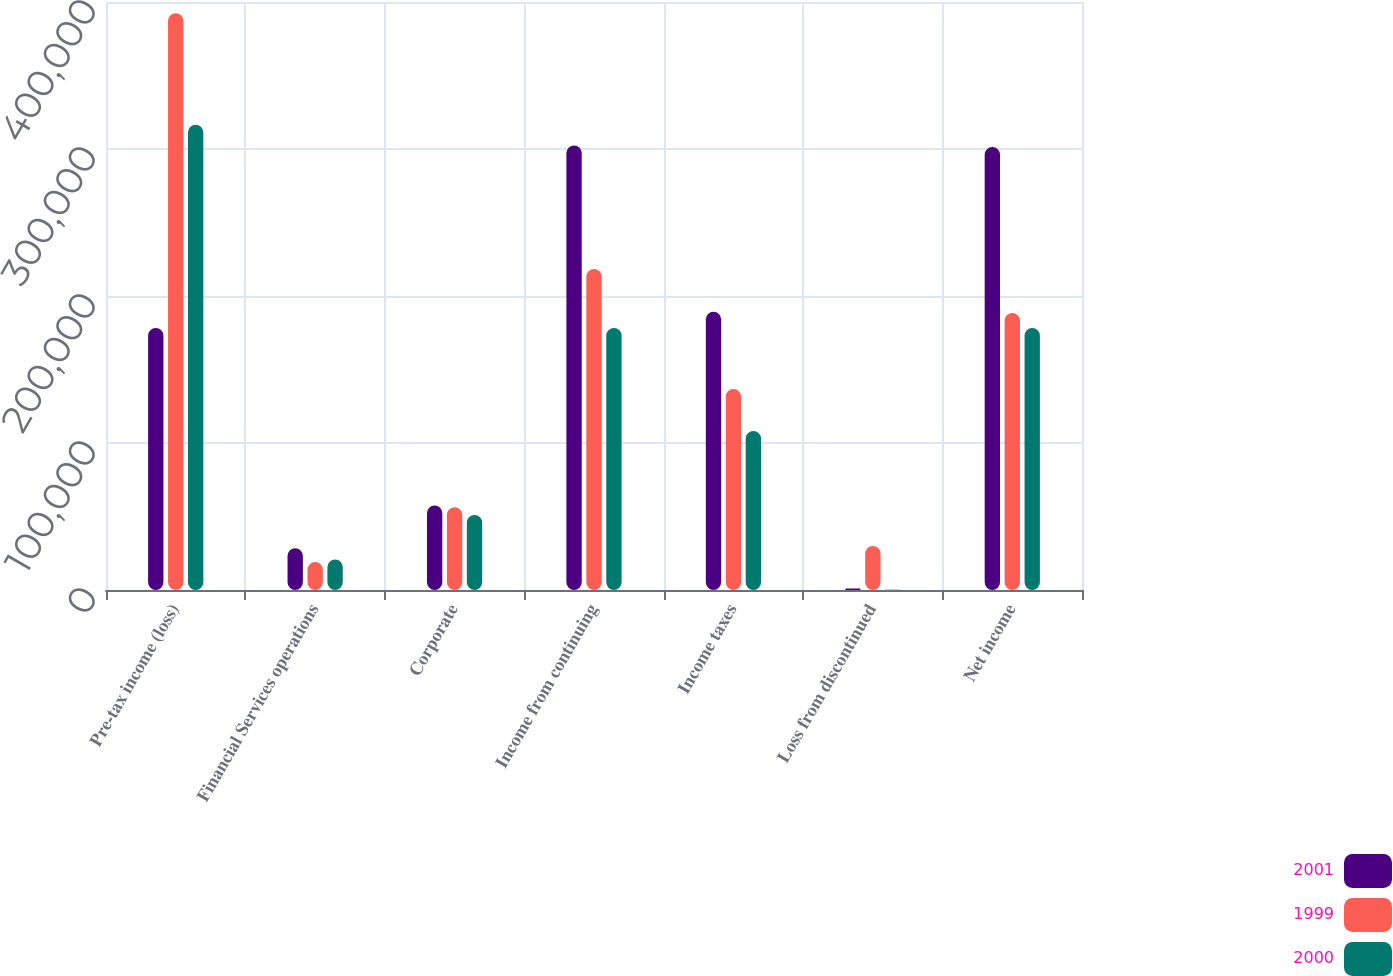Convert chart to OTSL. <chart><loc_0><loc_0><loc_500><loc_500><stacked_bar_chart><ecel><fcel>Pre-tax income (loss)<fcel>Financial Services operations<fcel>Corporate<fcel>Income from continuing<fcel>Income taxes<fcel>Loss from discontinued<fcel>Net income<nl><fcel>2001<fcel>178165<fcel>28331<fcel>57452<fcel>302425<fcel>189362<fcel>1032<fcel>301393<nl><fcel>1999<fcel>392383<fcel>19009<fcel>56296<fcel>218384<fcel>136712<fcel>29871<fcel>188513<nl><fcel>2000<fcel>316561<fcel>20828<fcel>50984<fcel>178287<fcel>108118<fcel>122<fcel>178165<nl></chart> 